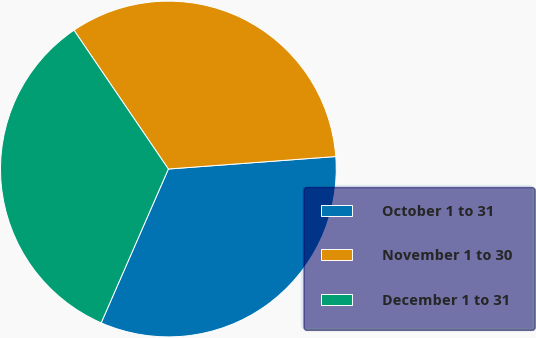<chart> <loc_0><loc_0><loc_500><loc_500><pie_chart><fcel>October 1 to 31<fcel>November 1 to 30<fcel>December 1 to 31<nl><fcel>32.74%<fcel>33.32%<fcel>33.94%<nl></chart> 